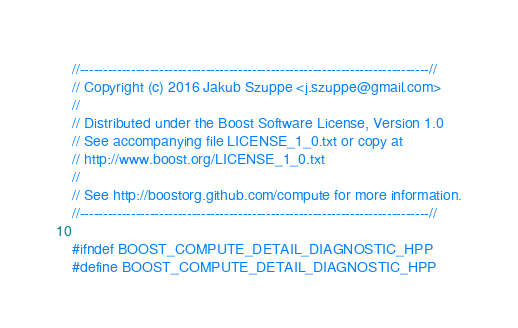<code> <loc_0><loc_0><loc_500><loc_500><_C++_>//---------------------------------------------------------------------------//
// Copyright (c) 2016 Jakub Szuppe <j.szuppe@gmail.com>
//
// Distributed under the Boost Software License, Version 1.0
// See accompanying file LICENSE_1_0.txt or copy at
// http://www.boost.org/LICENSE_1_0.txt
//
// See http://boostorg.github.com/compute for more information.
//---------------------------------------------------------------------------//

#ifndef BOOST_COMPUTE_DETAIL_DIAGNOSTIC_HPP
#define BOOST_COMPUTE_DETAIL_DIAGNOSTIC_HPP
</code> 